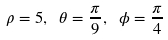<formula> <loc_0><loc_0><loc_500><loc_500>\rho = 5 , \ \theta = { \frac { \pi } { 9 } } , \ \phi = { \frac { \pi } { 4 } }</formula> 